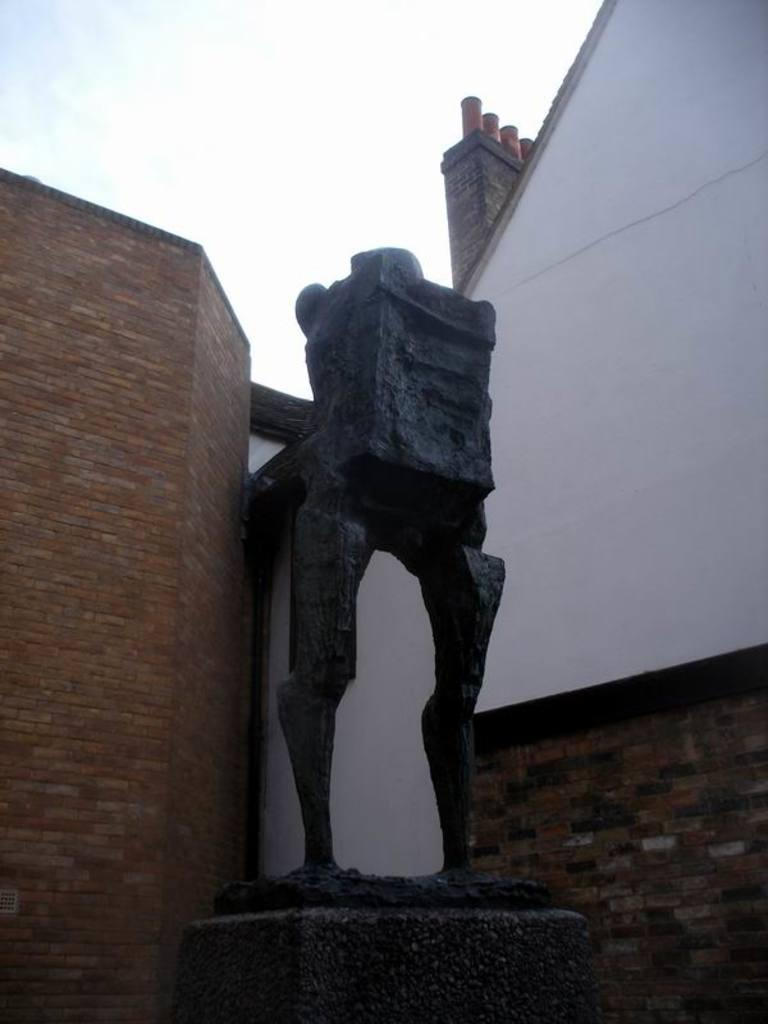What is the main subject of the image? The main subject of the image is a sculpture made up of stones. What other structure can be seen in the image? There is a building made up of bricks in the image. What part of the natural environment is visible in the image? The sky is visible in the image. How does the father interact with the sculpture in the image? There is no father present in the image, so it is not possible to determine how he might interact with the sculpture. 